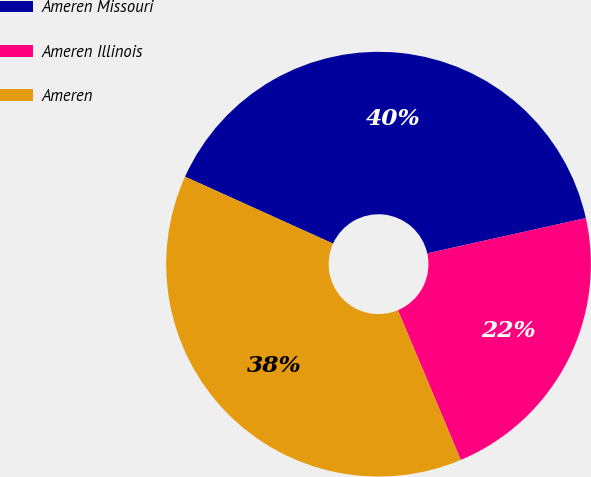Convert chart to OTSL. <chart><loc_0><loc_0><loc_500><loc_500><pie_chart><fcel>Ameren Missouri<fcel>Ameren Illinois<fcel>Ameren<nl><fcel>39.76%<fcel>22.15%<fcel>38.09%<nl></chart> 